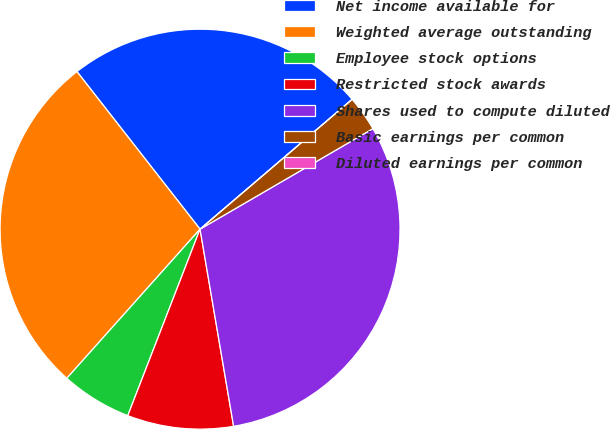<chart> <loc_0><loc_0><loc_500><loc_500><pie_chart><fcel>Net income available for<fcel>Weighted average outstanding<fcel>Employee stock options<fcel>Restricted stock awards<fcel>Shares used to compute diluted<fcel>Basic earnings per common<fcel>Diluted earnings per common<nl><fcel>24.31%<fcel>27.84%<fcel>5.72%<fcel>8.57%<fcel>30.7%<fcel>2.86%<fcel>0.0%<nl></chart> 